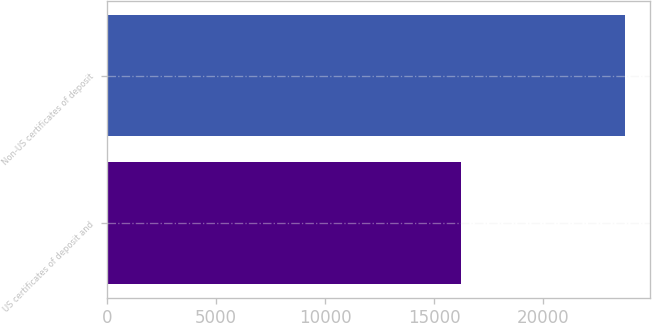<chart> <loc_0><loc_0><loc_500><loc_500><bar_chart><fcel>US certificates of deposit and<fcel>Non-US certificates of deposit<nl><fcel>16246<fcel>23726<nl></chart> 